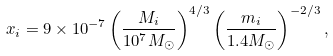Convert formula to latex. <formula><loc_0><loc_0><loc_500><loc_500>x _ { i } = 9 \times 1 0 ^ { - 7 } \left ( \frac { M _ { i } } { 1 0 ^ { 7 } M _ { \odot } } \right ) ^ { 4 / 3 } \left ( \frac { m _ { i } } { 1 . 4 M _ { \odot } } \right ) ^ { - 2 / 3 } ,</formula> 